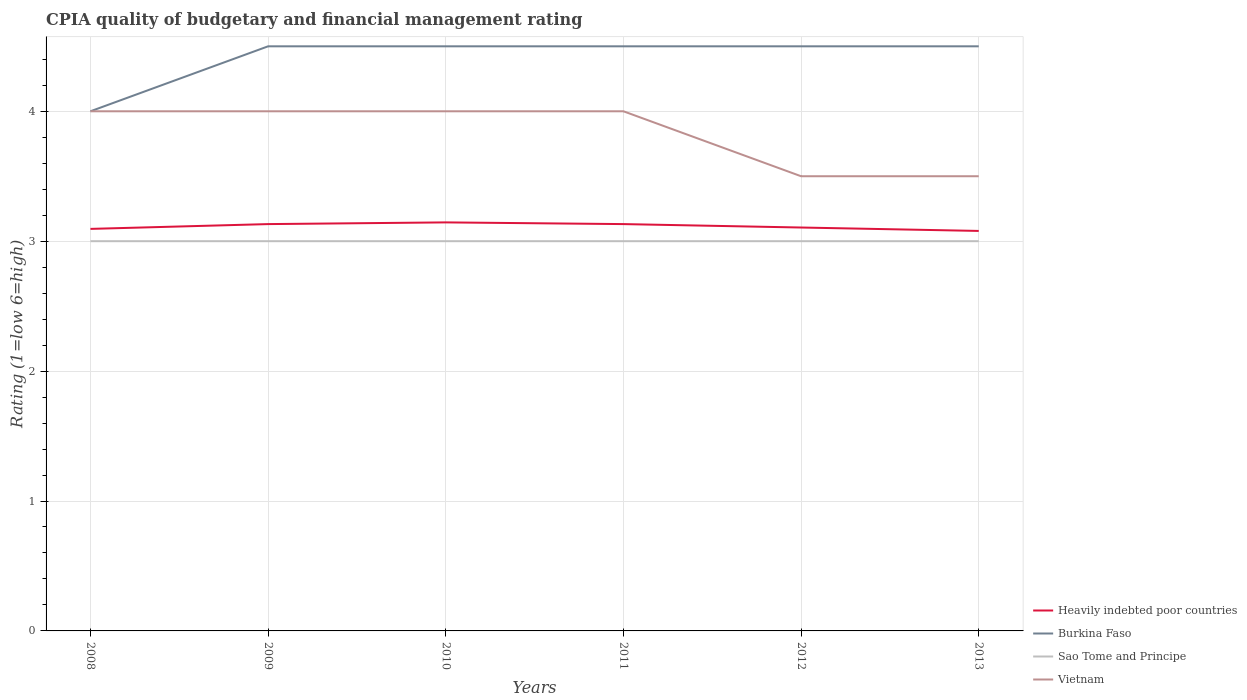How many different coloured lines are there?
Provide a short and direct response. 4. Does the line corresponding to Burkina Faso intersect with the line corresponding to Heavily indebted poor countries?
Provide a short and direct response. No. Is the number of lines equal to the number of legend labels?
Your answer should be compact. Yes. Across all years, what is the maximum CPIA rating in Sao Tome and Principe?
Your answer should be compact. 3. In which year was the CPIA rating in Heavily indebted poor countries maximum?
Your answer should be compact. 2013. What is the total CPIA rating in Sao Tome and Principe in the graph?
Make the answer very short. 0. What is the difference between the highest and the second highest CPIA rating in Burkina Faso?
Your answer should be compact. 0.5. How many lines are there?
Your answer should be compact. 4. How many years are there in the graph?
Offer a very short reply. 6. Does the graph contain any zero values?
Your response must be concise. No. What is the title of the graph?
Ensure brevity in your answer.  CPIA quality of budgetary and financial management rating. Does "Low & middle income" appear as one of the legend labels in the graph?
Offer a terse response. No. What is the label or title of the Y-axis?
Your answer should be very brief. Rating (1=low 6=high). What is the Rating (1=low 6=high) of Heavily indebted poor countries in 2008?
Keep it short and to the point. 3.09. What is the Rating (1=low 6=high) in Burkina Faso in 2008?
Make the answer very short. 4. What is the Rating (1=low 6=high) in Vietnam in 2008?
Provide a short and direct response. 4. What is the Rating (1=low 6=high) in Heavily indebted poor countries in 2009?
Keep it short and to the point. 3.13. What is the Rating (1=low 6=high) in Vietnam in 2009?
Provide a succinct answer. 4. What is the Rating (1=low 6=high) of Heavily indebted poor countries in 2010?
Your answer should be very brief. 3.14. What is the Rating (1=low 6=high) in Burkina Faso in 2010?
Your answer should be very brief. 4.5. What is the Rating (1=low 6=high) in Sao Tome and Principe in 2010?
Make the answer very short. 3. What is the Rating (1=low 6=high) of Vietnam in 2010?
Offer a very short reply. 4. What is the Rating (1=low 6=high) of Heavily indebted poor countries in 2011?
Your response must be concise. 3.13. What is the Rating (1=low 6=high) in Heavily indebted poor countries in 2012?
Offer a very short reply. 3.11. What is the Rating (1=low 6=high) of Burkina Faso in 2012?
Make the answer very short. 4.5. What is the Rating (1=low 6=high) of Sao Tome and Principe in 2012?
Your answer should be very brief. 3. What is the Rating (1=low 6=high) of Vietnam in 2012?
Your answer should be very brief. 3.5. What is the Rating (1=low 6=high) of Heavily indebted poor countries in 2013?
Offer a very short reply. 3.08. What is the Rating (1=low 6=high) of Burkina Faso in 2013?
Keep it short and to the point. 4.5. What is the Rating (1=low 6=high) of Vietnam in 2013?
Your answer should be very brief. 3.5. Across all years, what is the maximum Rating (1=low 6=high) of Heavily indebted poor countries?
Offer a terse response. 3.14. Across all years, what is the maximum Rating (1=low 6=high) in Vietnam?
Make the answer very short. 4. Across all years, what is the minimum Rating (1=low 6=high) in Heavily indebted poor countries?
Your answer should be very brief. 3.08. Across all years, what is the minimum Rating (1=low 6=high) of Burkina Faso?
Keep it short and to the point. 4. Across all years, what is the minimum Rating (1=low 6=high) of Sao Tome and Principe?
Give a very brief answer. 3. What is the total Rating (1=low 6=high) of Heavily indebted poor countries in the graph?
Provide a short and direct response. 18.69. What is the total Rating (1=low 6=high) in Burkina Faso in the graph?
Make the answer very short. 26.5. What is the total Rating (1=low 6=high) of Vietnam in the graph?
Provide a short and direct response. 23. What is the difference between the Rating (1=low 6=high) in Heavily indebted poor countries in 2008 and that in 2009?
Ensure brevity in your answer.  -0.04. What is the difference between the Rating (1=low 6=high) of Heavily indebted poor countries in 2008 and that in 2010?
Your answer should be compact. -0.05. What is the difference between the Rating (1=low 6=high) in Burkina Faso in 2008 and that in 2010?
Keep it short and to the point. -0.5. What is the difference between the Rating (1=low 6=high) of Vietnam in 2008 and that in 2010?
Provide a succinct answer. 0. What is the difference between the Rating (1=low 6=high) of Heavily indebted poor countries in 2008 and that in 2011?
Your answer should be compact. -0.04. What is the difference between the Rating (1=low 6=high) in Sao Tome and Principe in 2008 and that in 2011?
Your response must be concise. 0. What is the difference between the Rating (1=low 6=high) in Vietnam in 2008 and that in 2011?
Your answer should be very brief. 0. What is the difference between the Rating (1=low 6=high) in Heavily indebted poor countries in 2008 and that in 2012?
Your answer should be very brief. -0.01. What is the difference between the Rating (1=low 6=high) of Sao Tome and Principe in 2008 and that in 2012?
Ensure brevity in your answer.  0. What is the difference between the Rating (1=low 6=high) of Heavily indebted poor countries in 2008 and that in 2013?
Ensure brevity in your answer.  0.02. What is the difference between the Rating (1=low 6=high) in Sao Tome and Principe in 2008 and that in 2013?
Give a very brief answer. 0. What is the difference between the Rating (1=low 6=high) in Vietnam in 2008 and that in 2013?
Your response must be concise. 0.5. What is the difference between the Rating (1=low 6=high) in Heavily indebted poor countries in 2009 and that in 2010?
Make the answer very short. -0.01. What is the difference between the Rating (1=low 6=high) in Burkina Faso in 2009 and that in 2010?
Offer a terse response. 0. What is the difference between the Rating (1=low 6=high) of Vietnam in 2009 and that in 2011?
Make the answer very short. 0. What is the difference between the Rating (1=low 6=high) of Heavily indebted poor countries in 2009 and that in 2012?
Your answer should be compact. 0.03. What is the difference between the Rating (1=low 6=high) in Vietnam in 2009 and that in 2012?
Your response must be concise. 0.5. What is the difference between the Rating (1=low 6=high) of Heavily indebted poor countries in 2009 and that in 2013?
Your response must be concise. 0.05. What is the difference between the Rating (1=low 6=high) in Sao Tome and Principe in 2009 and that in 2013?
Give a very brief answer. 0. What is the difference between the Rating (1=low 6=high) in Vietnam in 2009 and that in 2013?
Provide a short and direct response. 0.5. What is the difference between the Rating (1=low 6=high) in Heavily indebted poor countries in 2010 and that in 2011?
Ensure brevity in your answer.  0.01. What is the difference between the Rating (1=low 6=high) of Heavily indebted poor countries in 2010 and that in 2012?
Your answer should be very brief. 0.04. What is the difference between the Rating (1=low 6=high) in Vietnam in 2010 and that in 2012?
Your answer should be compact. 0.5. What is the difference between the Rating (1=low 6=high) of Heavily indebted poor countries in 2010 and that in 2013?
Provide a short and direct response. 0.07. What is the difference between the Rating (1=low 6=high) of Burkina Faso in 2010 and that in 2013?
Your answer should be compact. 0. What is the difference between the Rating (1=low 6=high) in Vietnam in 2010 and that in 2013?
Provide a succinct answer. 0.5. What is the difference between the Rating (1=low 6=high) of Heavily indebted poor countries in 2011 and that in 2012?
Make the answer very short. 0.03. What is the difference between the Rating (1=low 6=high) in Burkina Faso in 2011 and that in 2012?
Your response must be concise. 0. What is the difference between the Rating (1=low 6=high) in Sao Tome and Principe in 2011 and that in 2012?
Keep it short and to the point. 0. What is the difference between the Rating (1=low 6=high) in Heavily indebted poor countries in 2011 and that in 2013?
Make the answer very short. 0.05. What is the difference between the Rating (1=low 6=high) of Sao Tome and Principe in 2011 and that in 2013?
Offer a terse response. 0. What is the difference between the Rating (1=low 6=high) in Vietnam in 2011 and that in 2013?
Your answer should be compact. 0.5. What is the difference between the Rating (1=low 6=high) of Heavily indebted poor countries in 2012 and that in 2013?
Make the answer very short. 0.03. What is the difference between the Rating (1=low 6=high) of Burkina Faso in 2012 and that in 2013?
Your answer should be very brief. 0. What is the difference between the Rating (1=low 6=high) of Sao Tome and Principe in 2012 and that in 2013?
Your answer should be compact. 0. What is the difference between the Rating (1=low 6=high) in Vietnam in 2012 and that in 2013?
Offer a very short reply. 0. What is the difference between the Rating (1=low 6=high) of Heavily indebted poor countries in 2008 and the Rating (1=low 6=high) of Burkina Faso in 2009?
Provide a short and direct response. -1.41. What is the difference between the Rating (1=low 6=high) in Heavily indebted poor countries in 2008 and the Rating (1=low 6=high) in Sao Tome and Principe in 2009?
Provide a short and direct response. 0.09. What is the difference between the Rating (1=low 6=high) of Heavily indebted poor countries in 2008 and the Rating (1=low 6=high) of Vietnam in 2009?
Your answer should be very brief. -0.91. What is the difference between the Rating (1=low 6=high) in Burkina Faso in 2008 and the Rating (1=low 6=high) in Sao Tome and Principe in 2009?
Ensure brevity in your answer.  1. What is the difference between the Rating (1=low 6=high) of Burkina Faso in 2008 and the Rating (1=low 6=high) of Vietnam in 2009?
Keep it short and to the point. 0. What is the difference between the Rating (1=low 6=high) of Heavily indebted poor countries in 2008 and the Rating (1=low 6=high) of Burkina Faso in 2010?
Offer a terse response. -1.41. What is the difference between the Rating (1=low 6=high) of Heavily indebted poor countries in 2008 and the Rating (1=low 6=high) of Sao Tome and Principe in 2010?
Ensure brevity in your answer.  0.09. What is the difference between the Rating (1=low 6=high) of Heavily indebted poor countries in 2008 and the Rating (1=low 6=high) of Vietnam in 2010?
Provide a succinct answer. -0.91. What is the difference between the Rating (1=low 6=high) of Burkina Faso in 2008 and the Rating (1=low 6=high) of Sao Tome and Principe in 2010?
Ensure brevity in your answer.  1. What is the difference between the Rating (1=low 6=high) of Sao Tome and Principe in 2008 and the Rating (1=low 6=high) of Vietnam in 2010?
Your response must be concise. -1. What is the difference between the Rating (1=low 6=high) in Heavily indebted poor countries in 2008 and the Rating (1=low 6=high) in Burkina Faso in 2011?
Keep it short and to the point. -1.41. What is the difference between the Rating (1=low 6=high) of Heavily indebted poor countries in 2008 and the Rating (1=low 6=high) of Sao Tome and Principe in 2011?
Your response must be concise. 0.09. What is the difference between the Rating (1=low 6=high) of Heavily indebted poor countries in 2008 and the Rating (1=low 6=high) of Vietnam in 2011?
Make the answer very short. -0.91. What is the difference between the Rating (1=low 6=high) in Burkina Faso in 2008 and the Rating (1=low 6=high) in Sao Tome and Principe in 2011?
Ensure brevity in your answer.  1. What is the difference between the Rating (1=low 6=high) of Sao Tome and Principe in 2008 and the Rating (1=low 6=high) of Vietnam in 2011?
Your answer should be compact. -1. What is the difference between the Rating (1=low 6=high) in Heavily indebted poor countries in 2008 and the Rating (1=low 6=high) in Burkina Faso in 2012?
Your answer should be compact. -1.41. What is the difference between the Rating (1=low 6=high) in Heavily indebted poor countries in 2008 and the Rating (1=low 6=high) in Sao Tome and Principe in 2012?
Your response must be concise. 0.09. What is the difference between the Rating (1=low 6=high) in Heavily indebted poor countries in 2008 and the Rating (1=low 6=high) in Vietnam in 2012?
Ensure brevity in your answer.  -0.41. What is the difference between the Rating (1=low 6=high) of Burkina Faso in 2008 and the Rating (1=low 6=high) of Vietnam in 2012?
Your answer should be compact. 0.5. What is the difference between the Rating (1=low 6=high) of Sao Tome and Principe in 2008 and the Rating (1=low 6=high) of Vietnam in 2012?
Give a very brief answer. -0.5. What is the difference between the Rating (1=low 6=high) of Heavily indebted poor countries in 2008 and the Rating (1=low 6=high) of Burkina Faso in 2013?
Keep it short and to the point. -1.41. What is the difference between the Rating (1=low 6=high) of Heavily indebted poor countries in 2008 and the Rating (1=low 6=high) of Sao Tome and Principe in 2013?
Offer a terse response. 0.09. What is the difference between the Rating (1=low 6=high) of Heavily indebted poor countries in 2008 and the Rating (1=low 6=high) of Vietnam in 2013?
Give a very brief answer. -0.41. What is the difference between the Rating (1=low 6=high) in Burkina Faso in 2008 and the Rating (1=low 6=high) in Sao Tome and Principe in 2013?
Keep it short and to the point. 1. What is the difference between the Rating (1=low 6=high) of Burkina Faso in 2008 and the Rating (1=low 6=high) of Vietnam in 2013?
Keep it short and to the point. 0.5. What is the difference between the Rating (1=low 6=high) in Heavily indebted poor countries in 2009 and the Rating (1=low 6=high) in Burkina Faso in 2010?
Provide a succinct answer. -1.37. What is the difference between the Rating (1=low 6=high) in Heavily indebted poor countries in 2009 and the Rating (1=low 6=high) in Sao Tome and Principe in 2010?
Your response must be concise. 0.13. What is the difference between the Rating (1=low 6=high) of Heavily indebted poor countries in 2009 and the Rating (1=low 6=high) of Vietnam in 2010?
Your answer should be very brief. -0.87. What is the difference between the Rating (1=low 6=high) in Heavily indebted poor countries in 2009 and the Rating (1=low 6=high) in Burkina Faso in 2011?
Provide a short and direct response. -1.37. What is the difference between the Rating (1=low 6=high) of Heavily indebted poor countries in 2009 and the Rating (1=low 6=high) of Sao Tome and Principe in 2011?
Offer a terse response. 0.13. What is the difference between the Rating (1=low 6=high) in Heavily indebted poor countries in 2009 and the Rating (1=low 6=high) in Vietnam in 2011?
Ensure brevity in your answer.  -0.87. What is the difference between the Rating (1=low 6=high) in Burkina Faso in 2009 and the Rating (1=low 6=high) in Sao Tome and Principe in 2011?
Offer a very short reply. 1.5. What is the difference between the Rating (1=low 6=high) of Burkina Faso in 2009 and the Rating (1=low 6=high) of Vietnam in 2011?
Ensure brevity in your answer.  0.5. What is the difference between the Rating (1=low 6=high) in Heavily indebted poor countries in 2009 and the Rating (1=low 6=high) in Burkina Faso in 2012?
Provide a short and direct response. -1.37. What is the difference between the Rating (1=low 6=high) in Heavily indebted poor countries in 2009 and the Rating (1=low 6=high) in Sao Tome and Principe in 2012?
Offer a terse response. 0.13. What is the difference between the Rating (1=low 6=high) of Heavily indebted poor countries in 2009 and the Rating (1=low 6=high) of Vietnam in 2012?
Keep it short and to the point. -0.37. What is the difference between the Rating (1=low 6=high) of Burkina Faso in 2009 and the Rating (1=low 6=high) of Sao Tome and Principe in 2012?
Your response must be concise. 1.5. What is the difference between the Rating (1=low 6=high) of Burkina Faso in 2009 and the Rating (1=low 6=high) of Vietnam in 2012?
Provide a succinct answer. 1. What is the difference between the Rating (1=low 6=high) of Heavily indebted poor countries in 2009 and the Rating (1=low 6=high) of Burkina Faso in 2013?
Make the answer very short. -1.37. What is the difference between the Rating (1=low 6=high) of Heavily indebted poor countries in 2009 and the Rating (1=low 6=high) of Sao Tome and Principe in 2013?
Offer a very short reply. 0.13. What is the difference between the Rating (1=low 6=high) in Heavily indebted poor countries in 2009 and the Rating (1=low 6=high) in Vietnam in 2013?
Provide a succinct answer. -0.37. What is the difference between the Rating (1=low 6=high) of Burkina Faso in 2009 and the Rating (1=low 6=high) of Sao Tome and Principe in 2013?
Your response must be concise. 1.5. What is the difference between the Rating (1=low 6=high) in Burkina Faso in 2009 and the Rating (1=low 6=high) in Vietnam in 2013?
Your response must be concise. 1. What is the difference between the Rating (1=low 6=high) of Sao Tome and Principe in 2009 and the Rating (1=low 6=high) of Vietnam in 2013?
Your answer should be very brief. -0.5. What is the difference between the Rating (1=low 6=high) of Heavily indebted poor countries in 2010 and the Rating (1=low 6=high) of Burkina Faso in 2011?
Your response must be concise. -1.36. What is the difference between the Rating (1=low 6=high) of Heavily indebted poor countries in 2010 and the Rating (1=low 6=high) of Sao Tome and Principe in 2011?
Offer a terse response. 0.14. What is the difference between the Rating (1=low 6=high) of Heavily indebted poor countries in 2010 and the Rating (1=low 6=high) of Vietnam in 2011?
Offer a very short reply. -0.86. What is the difference between the Rating (1=low 6=high) in Burkina Faso in 2010 and the Rating (1=low 6=high) in Sao Tome and Principe in 2011?
Offer a terse response. 1.5. What is the difference between the Rating (1=low 6=high) of Sao Tome and Principe in 2010 and the Rating (1=low 6=high) of Vietnam in 2011?
Offer a very short reply. -1. What is the difference between the Rating (1=low 6=high) in Heavily indebted poor countries in 2010 and the Rating (1=low 6=high) in Burkina Faso in 2012?
Your answer should be compact. -1.36. What is the difference between the Rating (1=low 6=high) of Heavily indebted poor countries in 2010 and the Rating (1=low 6=high) of Sao Tome and Principe in 2012?
Keep it short and to the point. 0.14. What is the difference between the Rating (1=low 6=high) of Heavily indebted poor countries in 2010 and the Rating (1=low 6=high) of Vietnam in 2012?
Ensure brevity in your answer.  -0.36. What is the difference between the Rating (1=low 6=high) in Burkina Faso in 2010 and the Rating (1=low 6=high) in Vietnam in 2012?
Your response must be concise. 1. What is the difference between the Rating (1=low 6=high) in Sao Tome and Principe in 2010 and the Rating (1=low 6=high) in Vietnam in 2012?
Your answer should be very brief. -0.5. What is the difference between the Rating (1=low 6=high) in Heavily indebted poor countries in 2010 and the Rating (1=low 6=high) in Burkina Faso in 2013?
Make the answer very short. -1.36. What is the difference between the Rating (1=low 6=high) of Heavily indebted poor countries in 2010 and the Rating (1=low 6=high) of Sao Tome and Principe in 2013?
Provide a short and direct response. 0.14. What is the difference between the Rating (1=low 6=high) of Heavily indebted poor countries in 2010 and the Rating (1=low 6=high) of Vietnam in 2013?
Offer a very short reply. -0.36. What is the difference between the Rating (1=low 6=high) in Burkina Faso in 2010 and the Rating (1=low 6=high) in Sao Tome and Principe in 2013?
Offer a very short reply. 1.5. What is the difference between the Rating (1=low 6=high) of Burkina Faso in 2010 and the Rating (1=low 6=high) of Vietnam in 2013?
Keep it short and to the point. 1. What is the difference between the Rating (1=low 6=high) of Heavily indebted poor countries in 2011 and the Rating (1=low 6=high) of Burkina Faso in 2012?
Make the answer very short. -1.37. What is the difference between the Rating (1=low 6=high) of Heavily indebted poor countries in 2011 and the Rating (1=low 6=high) of Sao Tome and Principe in 2012?
Give a very brief answer. 0.13. What is the difference between the Rating (1=low 6=high) of Heavily indebted poor countries in 2011 and the Rating (1=low 6=high) of Vietnam in 2012?
Offer a terse response. -0.37. What is the difference between the Rating (1=low 6=high) in Burkina Faso in 2011 and the Rating (1=low 6=high) in Sao Tome and Principe in 2012?
Your answer should be very brief. 1.5. What is the difference between the Rating (1=low 6=high) of Burkina Faso in 2011 and the Rating (1=low 6=high) of Vietnam in 2012?
Give a very brief answer. 1. What is the difference between the Rating (1=low 6=high) of Sao Tome and Principe in 2011 and the Rating (1=low 6=high) of Vietnam in 2012?
Make the answer very short. -0.5. What is the difference between the Rating (1=low 6=high) of Heavily indebted poor countries in 2011 and the Rating (1=low 6=high) of Burkina Faso in 2013?
Keep it short and to the point. -1.37. What is the difference between the Rating (1=low 6=high) of Heavily indebted poor countries in 2011 and the Rating (1=low 6=high) of Sao Tome and Principe in 2013?
Give a very brief answer. 0.13. What is the difference between the Rating (1=low 6=high) of Heavily indebted poor countries in 2011 and the Rating (1=low 6=high) of Vietnam in 2013?
Your response must be concise. -0.37. What is the difference between the Rating (1=low 6=high) of Burkina Faso in 2011 and the Rating (1=low 6=high) of Sao Tome and Principe in 2013?
Your response must be concise. 1.5. What is the difference between the Rating (1=low 6=high) of Heavily indebted poor countries in 2012 and the Rating (1=low 6=high) of Burkina Faso in 2013?
Your response must be concise. -1.39. What is the difference between the Rating (1=low 6=high) in Heavily indebted poor countries in 2012 and the Rating (1=low 6=high) in Sao Tome and Principe in 2013?
Your answer should be compact. 0.11. What is the difference between the Rating (1=low 6=high) of Heavily indebted poor countries in 2012 and the Rating (1=low 6=high) of Vietnam in 2013?
Provide a succinct answer. -0.39. What is the average Rating (1=low 6=high) in Heavily indebted poor countries per year?
Give a very brief answer. 3.11. What is the average Rating (1=low 6=high) in Burkina Faso per year?
Make the answer very short. 4.42. What is the average Rating (1=low 6=high) of Vietnam per year?
Give a very brief answer. 3.83. In the year 2008, what is the difference between the Rating (1=low 6=high) in Heavily indebted poor countries and Rating (1=low 6=high) in Burkina Faso?
Your response must be concise. -0.91. In the year 2008, what is the difference between the Rating (1=low 6=high) of Heavily indebted poor countries and Rating (1=low 6=high) of Sao Tome and Principe?
Offer a terse response. 0.09. In the year 2008, what is the difference between the Rating (1=low 6=high) in Heavily indebted poor countries and Rating (1=low 6=high) in Vietnam?
Give a very brief answer. -0.91. In the year 2008, what is the difference between the Rating (1=low 6=high) in Burkina Faso and Rating (1=low 6=high) in Vietnam?
Offer a very short reply. 0. In the year 2008, what is the difference between the Rating (1=low 6=high) of Sao Tome and Principe and Rating (1=low 6=high) of Vietnam?
Your answer should be compact. -1. In the year 2009, what is the difference between the Rating (1=low 6=high) of Heavily indebted poor countries and Rating (1=low 6=high) of Burkina Faso?
Provide a succinct answer. -1.37. In the year 2009, what is the difference between the Rating (1=low 6=high) in Heavily indebted poor countries and Rating (1=low 6=high) in Sao Tome and Principe?
Keep it short and to the point. 0.13. In the year 2009, what is the difference between the Rating (1=low 6=high) of Heavily indebted poor countries and Rating (1=low 6=high) of Vietnam?
Keep it short and to the point. -0.87. In the year 2009, what is the difference between the Rating (1=low 6=high) of Burkina Faso and Rating (1=low 6=high) of Vietnam?
Ensure brevity in your answer.  0.5. In the year 2010, what is the difference between the Rating (1=low 6=high) of Heavily indebted poor countries and Rating (1=low 6=high) of Burkina Faso?
Ensure brevity in your answer.  -1.36. In the year 2010, what is the difference between the Rating (1=low 6=high) in Heavily indebted poor countries and Rating (1=low 6=high) in Sao Tome and Principe?
Offer a very short reply. 0.14. In the year 2010, what is the difference between the Rating (1=low 6=high) in Heavily indebted poor countries and Rating (1=low 6=high) in Vietnam?
Give a very brief answer. -0.86. In the year 2010, what is the difference between the Rating (1=low 6=high) of Sao Tome and Principe and Rating (1=low 6=high) of Vietnam?
Your answer should be compact. -1. In the year 2011, what is the difference between the Rating (1=low 6=high) of Heavily indebted poor countries and Rating (1=low 6=high) of Burkina Faso?
Give a very brief answer. -1.37. In the year 2011, what is the difference between the Rating (1=low 6=high) of Heavily indebted poor countries and Rating (1=low 6=high) of Sao Tome and Principe?
Make the answer very short. 0.13. In the year 2011, what is the difference between the Rating (1=low 6=high) of Heavily indebted poor countries and Rating (1=low 6=high) of Vietnam?
Your answer should be compact. -0.87. In the year 2011, what is the difference between the Rating (1=low 6=high) in Burkina Faso and Rating (1=low 6=high) in Vietnam?
Provide a succinct answer. 0.5. In the year 2011, what is the difference between the Rating (1=low 6=high) of Sao Tome and Principe and Rating (1=low 6=high) of Vietnam?
Your answer should be compact. -1. In the year 2012, what is the difference between the Rating (1=low 6=high) in Heavily indebted poor countries and Rating (1=low 6=high) in Burkina Faso?
Your response must be concise. -1.39. In the year 2012, what is the difference between the Rating (1=low 6=high) of Heavily indebted poor countries and Rating (1=low 6=high) of Sao Tome and Principe?
Give a very brief answer. 0.11. In the year 2012, what is the difference between the Rating (1=low 6=high) of Heavily indebted poor countries and Rating (1=low 6=high) of Vietnam?
Ensure brevity in your answer.  -0.39. In the year 2012, what is the difference between the Rating (1=low 6=high) of Burkina Faso and Rating (1=low 6=high) of Sao Tome and Principe?
Your response must be concise. 1.5. In the year 2012, what is the difference between the Rating (1=low 6=high) of Sao Tome and Principe and Rating (1=low 6=high) of Vietnam?
Provide a succinct answer. -0.5. In the year 2013, what is the difference between the Rating (1=low 6=high) in Heavily indebted poor countries and Rating (1=low 6=high) in Burkina Faso?
Your answer should be compact. -1.42. In the year 2013, what is the difference between the Rating (1=low 6=high) in Heavily indebted poor countries and Rating (1=low 6=high) in Sao Tome and Principe?
Keep it short and to the point. 0.08. In the year 2013, what is the difference between the Rating (1=low 6=high) in Heavily indebted poor countries and Rating (1=low 6=high) in Vietnam?
Ensure brevity in your answer.  -0.42. In the year 2013, what is the difference between the Rating (1=low 6=high) of Burkina Faso and Rating (1=low 6=high) of Sao Tome and Principe?
Your answer should be compact. 1.5. What is the ratio of the Rating (1=low 6=high) of Sao Tome and Principe in 2008 to that in 2009?
Provide a succinct answer. 1. What is the ratio of the Rating (1=low 6=high) of Vietnam in 2008 to that in 2009?
Your response must be concise. 1. What is the ratio of the Rating (1=low 6=high) of Heavily indebted poor countries in 2008 to that in 2010?
Your response must be concise. 0.98. What is the ratio of the Rating (1=low 6=high) of Burkina Faso in 2008 to that in 2010?
Keep it short and to the point. 0.89. What is the ratio of the Rating (1=low 6=high) in Sao Tome and Principe in 2008 to that in 2010?
Your answer should be very brief. 1. What is the ratio of the Rating (1=low 6=high) of Vietnam in 2008 to that in 2010?
Your answer should be very brief. 1. What is the ratio of the Rating (1=low 6=high) in Sao Tome and Principe in 2008 to that in 2012?
Keep it short and to the point. 1. What is the ratio of the Rating (1=low 6=high) in Sao Tome and Principe in 2008 to that in 2013?
Offer a very short reply. 1. What is the ratio of the Rating (1=low 6=high) of Vietnam in 2008 to that in 2013?
Provide a succinct answer. 1.14. What is the ratio of the Rating (1=low 6=high) in Burkina Faso in 2009 to that in 2010?
Your answer should be very brief. 1. What is the ratio of the Rating (1=low 6=high) of Sao Tome and Principe in 2009 to that in 2010?
Ensure brevity in your answer.  1. What is the ratio of the Rating (1=low 6=high) in Heavily indebted poor countries in 2009 to that in 2011?
Your answer should be compact. 1. What is the ratio of the Rating (1=low 6=high) in Sao Tome and Principe in 2009 to that in 2011?
Give a very brief answer. 1. What is the ratio of the Rating (1=low 6=high) of Vietnam in 2009 to that in 2011?
Your answer should be very brief. 1. What is the ratio of the Rating (1=low 6=high) in Heavily indebted poor countries in 2009 to that in 2012?
Your answer should be compact. 1.01. What is the ratio of the Rating (1=low 6=high) of Heavily indebted poor countries in 2009 to that in 2013?
Give a very brief answer. 1.02. What is the ratio of the Rating (1=low 6=high) in Vietnam in 2009 to that in 2013?
Make the answer very short. 1.14. What is the ratio of the Rating (1=low 6=high) in Burkina Faso in 2010 to that in 2011?
Offer a very short reply. 1. What is the ratio of the Rating (1=low 6=high) of Heavily indebted poor countries in 2010 to that in 2012?
Ensure brevity in your answer.  1.01. What is the ratio of the Rating (1=low 6=high) of Heavily indebted poor countries in 2010 to that in 2013?
Keep it short and to the point. 1.02. What is the ratio of the Rating (1=low 6=high) of Burkina Faso in 2010 to that in 2013?
Provide a succinct answer. 1. What is the ratio of the Rating (1=low 6=high) of Vietnam in 2010 to that in 2013?
Give a very brief answer. 1.14. What is the ratio of the Rating (1=low 6=high) in Heavily indebted poor countries in 2011 to that in 2012?
Give a very brief answer. 1.01. What is the ratio of the Rating (1=low 6=high) in Burkina Faso in 2011 to that in 2012?
Keep it short and to the point. 1. What is the ratio of the Rating (1=low 6=high) in Vietnam in 2011 to that in 2012?
Offer a terse response. 1.14. What is the ratio of the Rating (1=low 6=high) of Heavily indebted poor countries in 2011 to that in 2013?
Your response must be concise. 1.02. What is the ratio of the Rating (1=low 6=high) in Sao Tome and Principe in 2011 to that in 2013?
Ensure brevity in your answer.  1. What is the ratio of the Rating (1=low 6=high) of Vietnam in 2011 to that in 2013?
Your answer should be compact. 1.14. What is the ratio of the Rating (1=low 6=high) of Heavily indebted poor countries in 2012 to that in 2013?
Ensure brevity in your answer.  1.01. What is the ratio of the Rating (1=low 6=high) in Burkina Faso in 2012 to that in 2013?
Provide a succinct answer. 1. What is the difference between the highest and the second highest Rating (1=low 6=high) in Heavily indebted poor countries?
Your answer should be very brief. 0.01. What is the difference between the highest and the second highest Rating (1=low 6=high) of Burkina Faso?
Your answer should be very brief. 0. What is the difference between the highest and the second highest Rating (1=low 6=high) in Vietnam?
Give a very brief answer. 0. What is the difference between the highest and the lowest Rating (1=low 6=high) in Heavily indebted poor countries?
Provide a succinct answer. 0.07. What is the difference between the highest and the lowest Rating (1=low 6=high) in Burkina Faso?
Your answer should be compact. 0.5. 